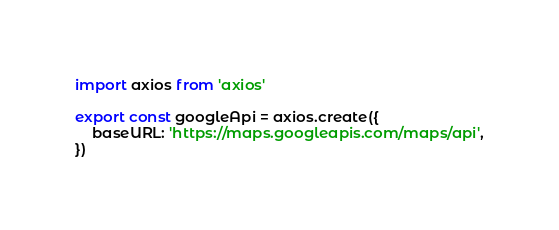Convert code to text. <code><loc_0><loc_0><loc_500><loc_500><_JavaScript_>import axios from 'axios'

export const googleApi = axios.create({
	baseURL: 'https://maps.googleapis.com/maps/api',
})
</code> 